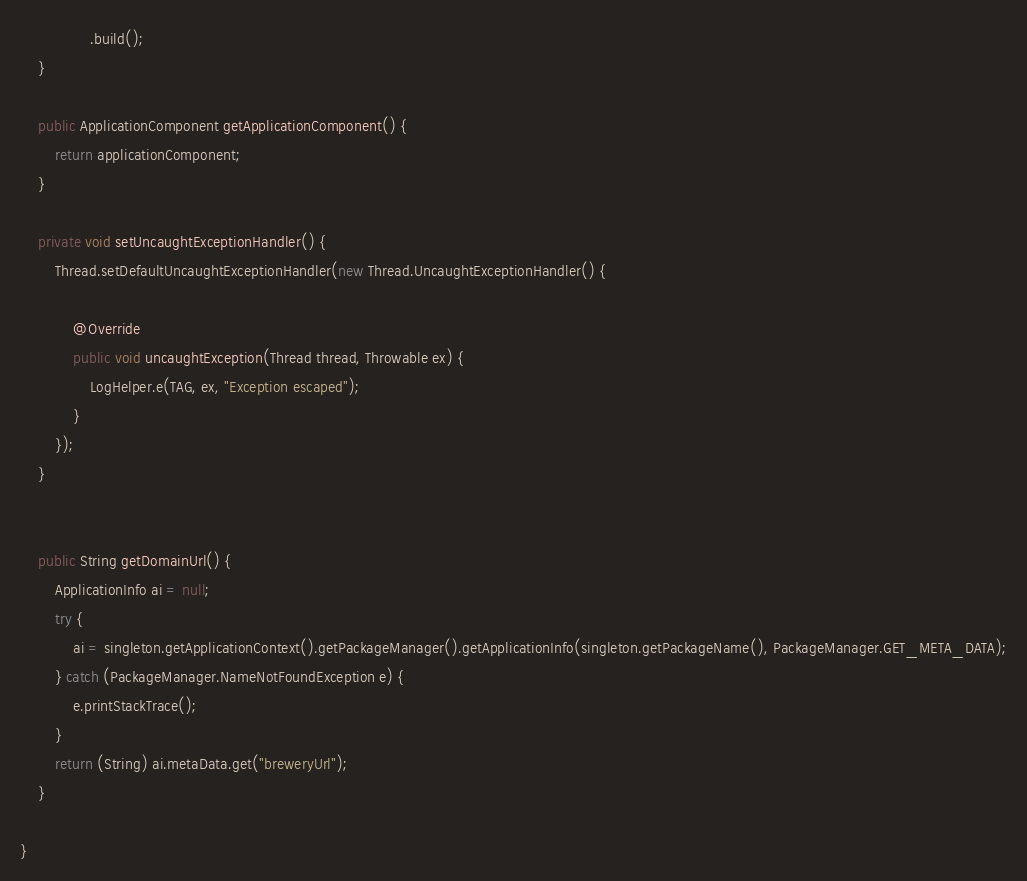<code> <loc_0><loc_0><loc_500><loc_500><_Java_>                .build();
    }

    public ApplicationComponent getApplicationComponent() {
        return applicationComponent;
    }

    private void setUncaughtExceptionHandler() {
        Thread.setDefaultUncaughtExceptionHandler(new Thread.UncaughtExceptionHandler() {

            @Override
            public void uncaughtException(Thread thread, Throwable ex) {
                LogHelper.e(TAG, ex, "Exception escaped");
            }
        });
    }


    public String getDomainUrl() {
        ApplicationInfo ai = null;
        try {
            ai = singleton.getApplicationContext().getPackageManager().getApplicationInfo(singleton.getPackageName(), PackageManager.GET_META_DATA);
        } catch (PackageManager.NameNotFoundException e) {
            e.printStackTrace();
        }
        return (String) ai.metaData.get("breweryUrl");
    }

}
</code> 